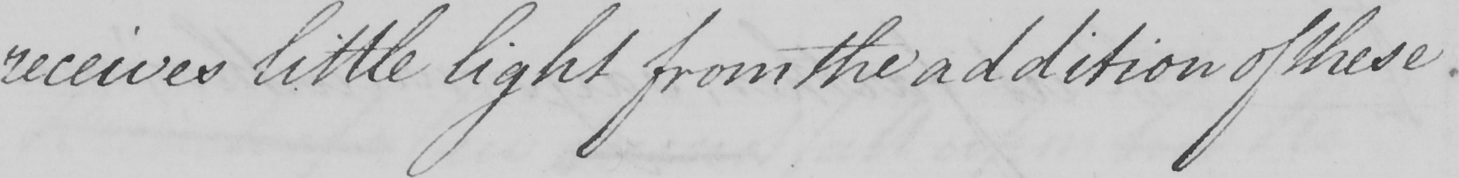Please provide the text content of this handwritten line. receives little light from the addition of these 